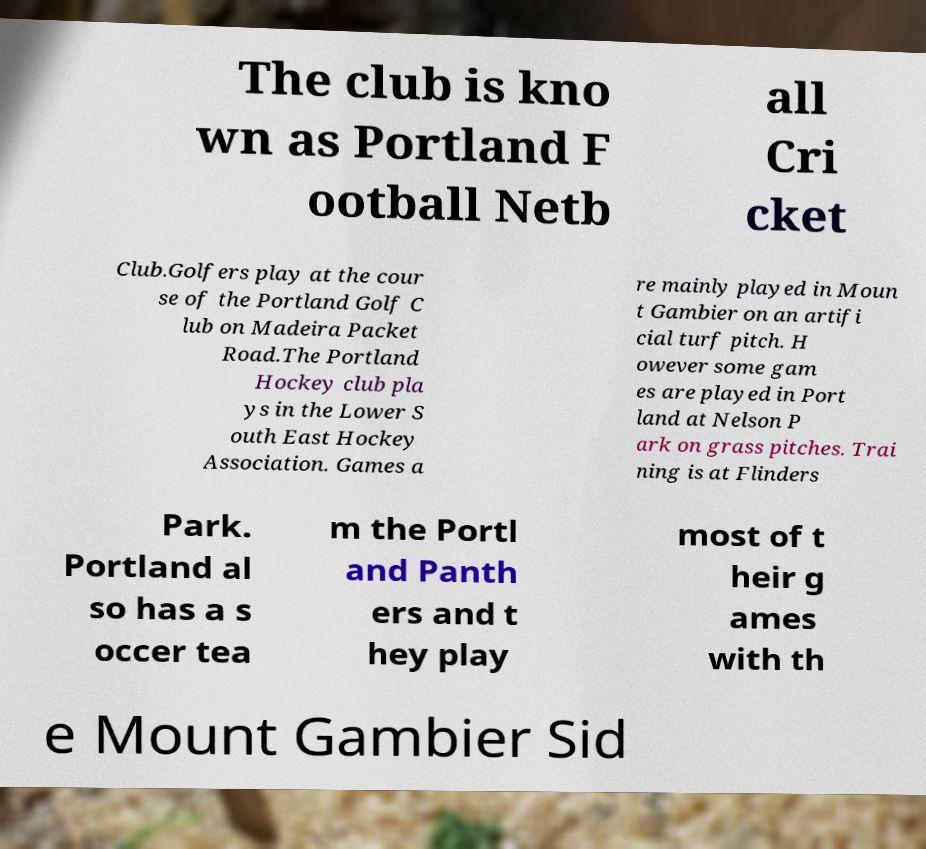I need the written content from this picture converted into text. Can you do that? The club is kno wn as Portland F ootball Netb all Cri cket Club.Golfers play at the cour se of the Portland Golf C lub on Madeira Packet Road.The Portland Hockey club pla ys in the Lower S outh East Hockey Association. Games a re mainly played in Moun t Gambier on an artifi cial turf pitch. H owever some gam es are played in Port land at Nelson P ark on grass pitches. Trai ning is at Flinders Park. Portland al so has a s occer tea m the Portl and Panth ers and t hey play most of t heir g ames with th e Mount Gambier Sid 